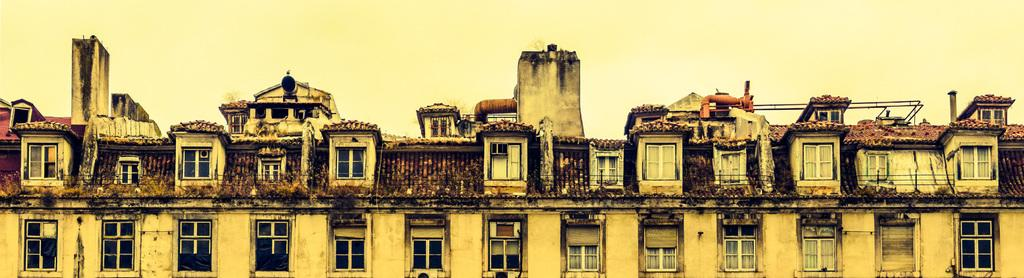What is the main structure in the image? There is a building in the image. What feature can be seen on the building? There are windows in the building. What can be seen in the distance in the image? The sky is visible in the background of the image. How many guides are visible in the image? There are no guides present in the image; it only features a building and the sky. What type of thumb is shown interacting with the building in the image? There is no thumb present in the image; it only features a building and the sky. 